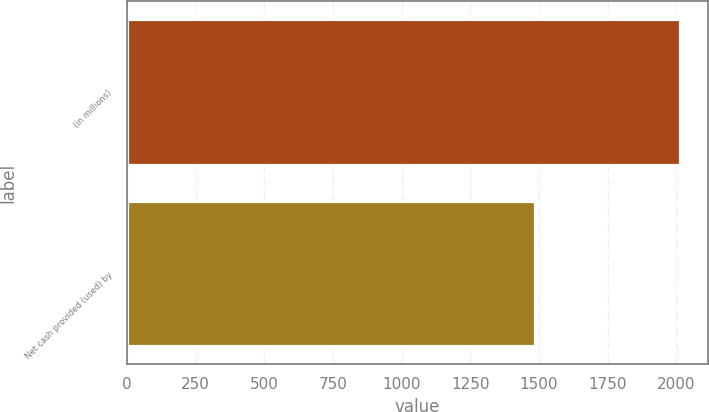Convert chart to OTSL. <chart><loc_0><loc_0><loc_500><loc_500><bar_chart><fcel>(in millions)<fcel>Net cash provided (used) by<nl><fcel>2015<fcel>1484<nl></chart> 